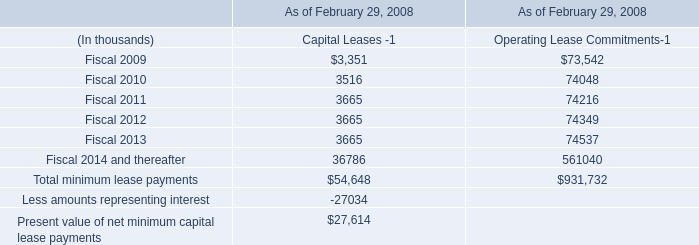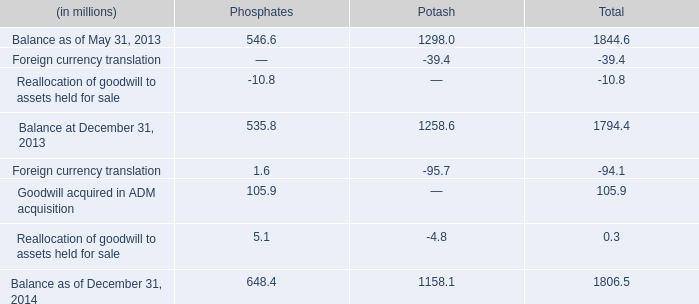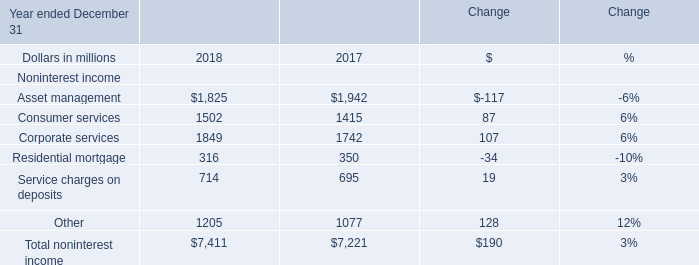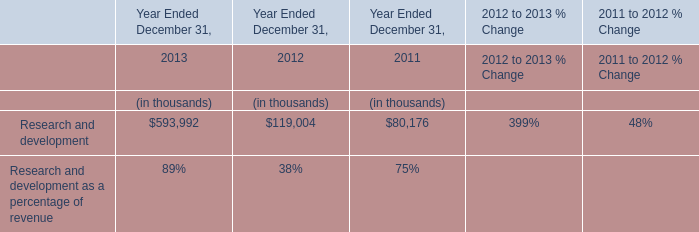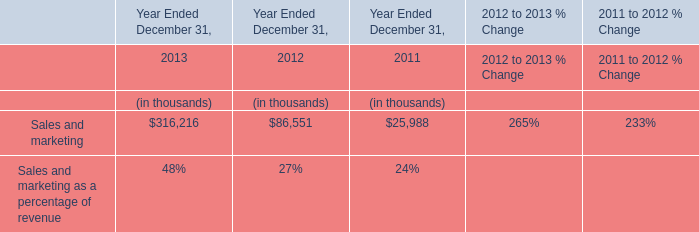What's the greatest value of Consumer services in 2018? 
Answer: 2018. 